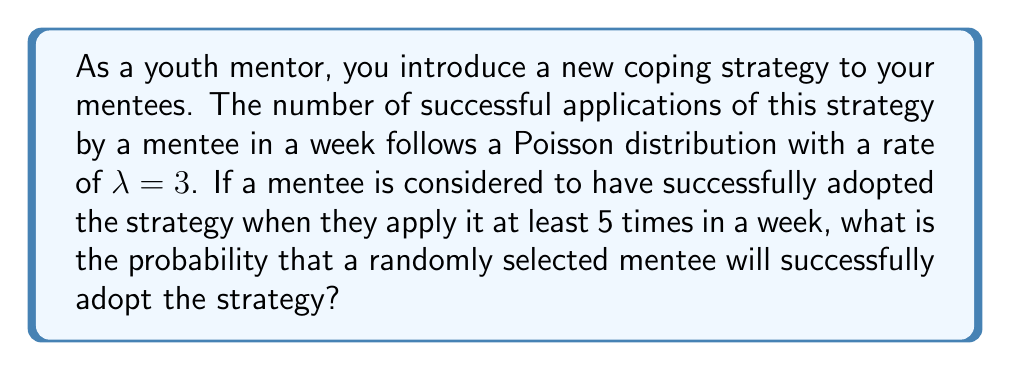Can you answer this question? Let's approach this step-by-step:

1) We are dealing with a Poisson process where:
   $\lambda = 3$ (rate parameter)
   $X$ = number of successful applications in a week

2) We need to find $P(X \geq 5)$, as success is defined as applying the strategy at least 5 times.

3) It's often easier to calculate this as $1 - P(X \leq 4)$:

   $P(X \geq 5) = 1 - P(X \leq 4)$

4) For a Poisson distribution, the probability of exactly $k$ events is given by:

   $P(X = k) = \frac{e^{-\lambda}\lambda^k}{k!}$

5) So, we need to calculate:

   $1 - [P(X = 0) + P(X = 1) + P(X = 2) + P(X = 3) + P(X = 4)]$

6) Let's calculate each term:

   $P(X = 0) = \frac{e^{-3}3^0}{0!} = e^{-3} \approx 0.0498$
   
   $P(X = 1) = \frac{e^{-3}3^1}{1!} = 3e^{-3} \approx 0.1494$
   
   $P(X = 2) = \frac{e^{-3}3^2}{2!} = \frac{9e^{-3}}{2} \approx 0.2240$
   
   $P(X = 3) = \frac{e^{-3}3^3}{3!} = 9e^{-3} \approx 0.2240$
   
   $P(X = 4) = \frac{e^{-3}3^4}{4!} = \frac{81e^{-3}}{8} \approx 0.1680$

7) Sum these probabilities:

   $P(X \leq 4) = 0.0498 + 0.1494 + 0.2240 + 0.2240 + 0.1680 = 0.8152$

8) Therefore, $P(X \geq 5) = 1 - 0.8152 = 0.1848$
Answer: 0.1848 